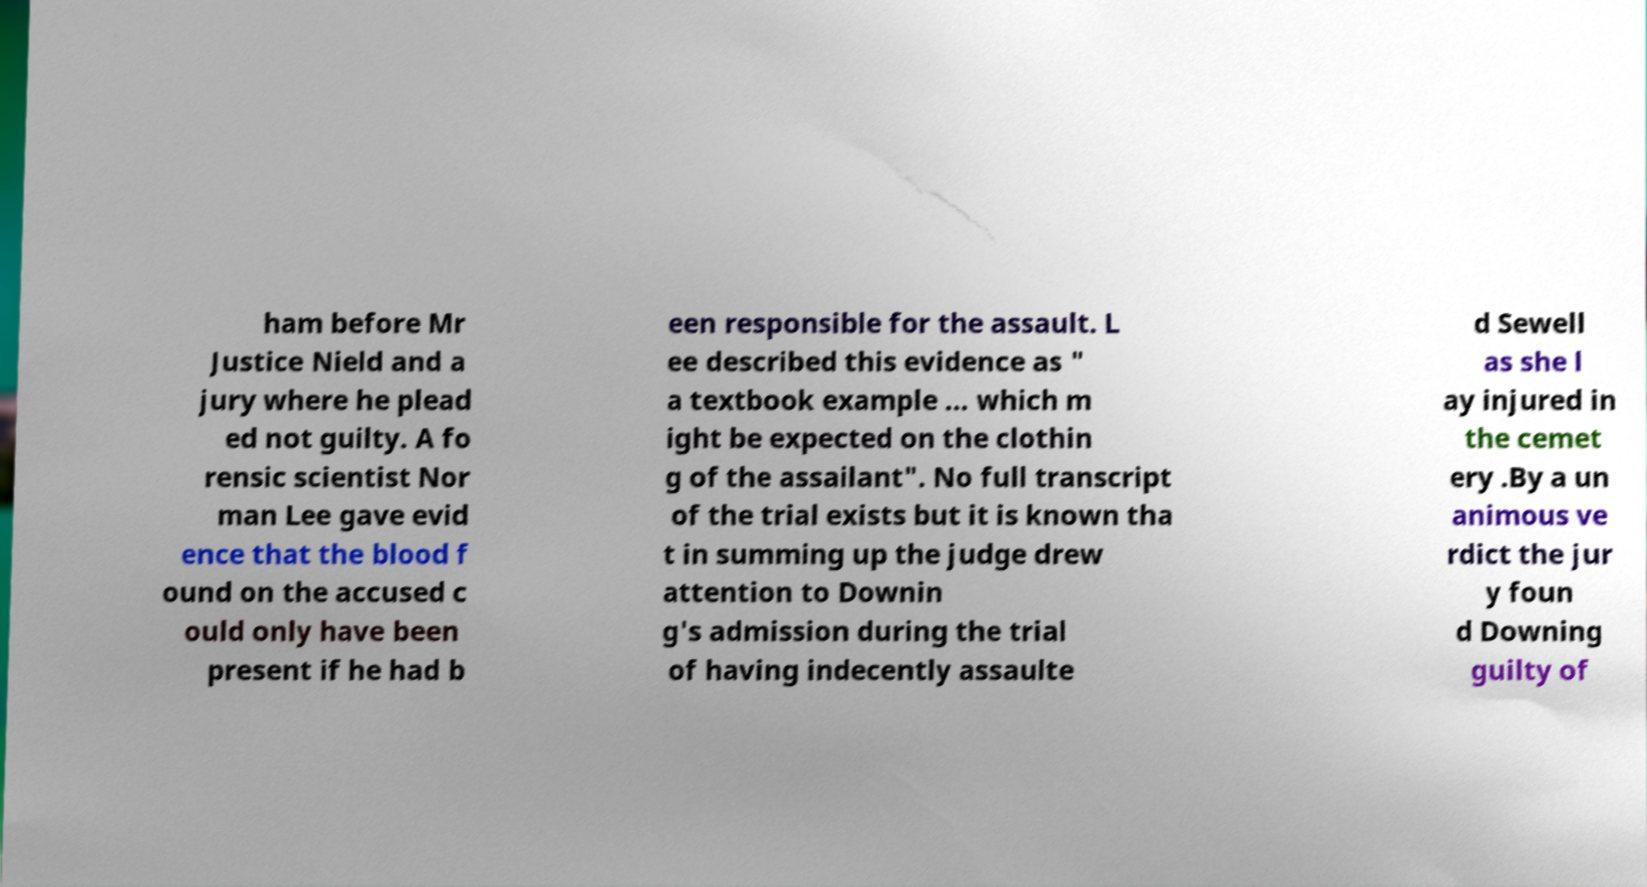What messages or text are displayed in this image? I need them in a readable, typed format. ham before Mr Justice Nield and a jury where he plead ed not guilty. A fo rensic scientist Nor man Lee gave evid ence that the blood f ound on the accused c ould only have been present if he had b een responsible for the assault. L ee described this evidence as " a textbook example ... which m ight be expected on the clothin g of the assailant". No full transcript of the trial exists but it is known tha t in summing up the judge drew attention to Downin g's admission during the trial of having indecently assaulte d Sewell as she l ay injured in the cemet ery .By a un animous ve rdict the jur y foun d Downing guilty of 